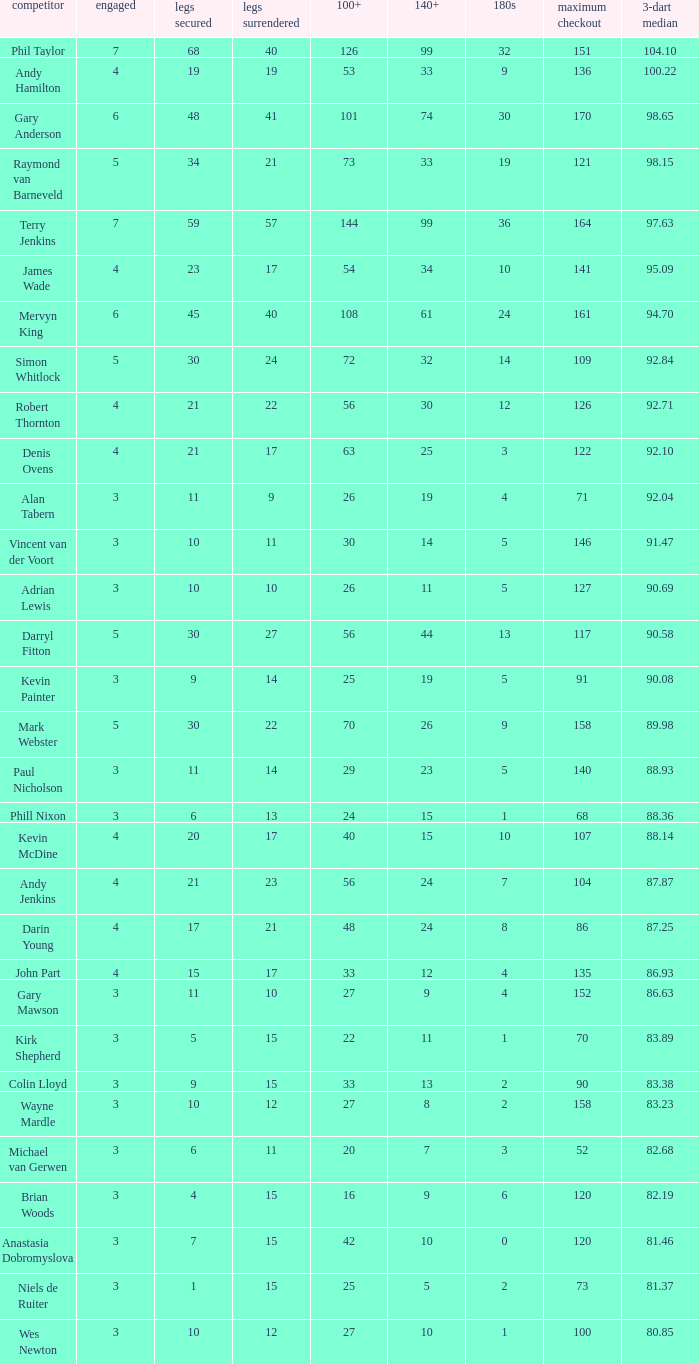Can you parse all the data within this table? {'header': ['competitor', 'engaged', 'legs secured', 'legs surrendered', '100+', '140+', '180s', 'maximum checkout', '3-dart median'], 'rows': [['Phil Taylor', '7', '68', '40', '126', '99', '32', '151', '104.10'], ['Andy Hamilton', '4', '19', '19', '53', '33', '9', '136', '100.22'], ['Gary Anderson', '6', '48', '41', '101', '74', '30', '170', '98.65'], ['Raymond van Barneveld', '5', '34', '21', '73', '33', '19', '121', '98.15'], ['Terry Jenkins', '7', '59', '57', '144', '99', '36', '164', '97.63'], ['James Wade', '4', '23', '17', '54', '34', '10', '141', '95.09'], ['Mervyn King', '6', '45', '40', '108', '61', '24', '161', '94.70'], ['Simon Whitlock', '5', '30', '24', '72', '32', '14', '109', '92.84'], ['Robert Thornton', '4', '21', '22', '56', '30', '12', '126', '92.71'], ['Denis Ovens', '4', '21', '17', '63', '25', '3', '122', '92.10'], ['Alan Tabern', '3', '11', '9', '26', '19', '4', '71', '92.04'], ['Vincent van der Voort', '3', '10', '11', '30', '14', '5', '146', '91.47'], ['Adrian Lewis', '3', '10', '10', '26', '11', '5', '127', '90.69'], ['Darryl Fitton', '5', '30', '27', '56', '44', '13', '117', '90.58'], ['Kevin Painter', '3', '9', '14', '25', '19', '5', '91', '90.08'], ['Mark Webster', '5', '30', '22', '70', '26', '9', '158', '89.98'], ['Paul Nicholson', '3', '11', '14', '29', '23', '5', '140', '88.93'], ['Phill Nixon', '3', '6', '13', '24', '15', '1', '68', '88.36'], ['Kevin McDine', '4', '20', '17', '40', '15', '10', '107', '88.14'], ['Andy Jenkins', '4', '21', '23', '56', '24', '7', '104', '87.87'], ['Darin Young', '4', '17', '21', '48', '24', '8', '86', '87.25'], ['John Part', '4', '15', '17', '33', '12', '4', '135', '86.93'], ['Gary Mawson', '3', '11', '10', '27', '9', '4', '152', '86.63'], ['Kirk Shepherd', '3', '5', '15', '22', '11', '1', '70', '83.89'], ['Colin Lloyd', '3', '9', '15', '33', '13', '2', '90', '83.38'], ['Wayne Mardle', '3', '10', '12', '27', '8', '2', '158', '83.23'], ['Michael van Gerwen', '3', '6', '11', '20', '7', '3', '52', '82.68'], ['Brian Woods', '3', '4', '15', '16', '9', '6', '120', '82.19'], ['Anastasia Dobromyslova', '3', '7', '15', '42', '10', '0', '120', '81.46'], ['Niels de Ruiter', '3', '1', '15', '25', '5', '2', '73', '81.37'], ['Wes Newton', '3', '10', '12', '27', '10', '1', '100', '80.85']]} Who is the player with 41 legs lost? Gary Anderson. 